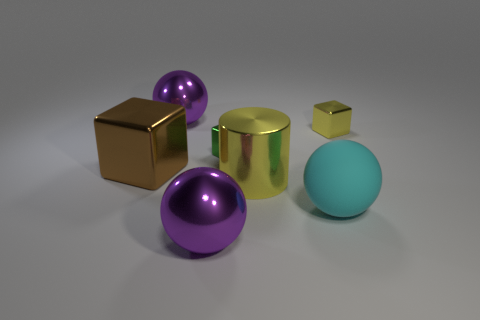Are there any other things that are the same shape as the large yellow shiny object?
Give a very brief answer. No. Are there fewer green metal blocks on the right side of the yellow metallic cylinder than tiny metal blocks that are on the right side of the big matte sphere?
Ensure brevity in your answer.  Yes. How big is the yellow cube right of the large cyan rubber object?
Your answer should be compact. Small. Does the green metallic block have the same size as the yellow cube?
Offer a terse response. Yes. What number of big balls are both left of the cyan sphere and in front of the big block?
Provide a short and direct response. 1. What number of yellow things are tiny metallic objects or cubes?
Ensure brevity in your answer.  1. How many metal things are small brown objects or yellow cylinders?
Make the answer very short. 1. Are there any red rubber blocks?
Your response must be concise. No. Does the brown metal object have the same shape as the green object?
Your answer should be very brief. Yes. What number of big shiny objects are to the left of the large purple object that is in front of the tiny shiny cube to the left of the rubber thing?
Your answer should be compact. 2. 